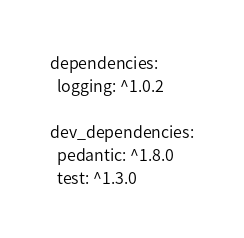<code> <loc_0><loc_0><loc_500><loc_500><_YAML_>dependencies:
  logging: ^1.0.2

dev_dependencies:
  pedantic: ^1.8.0
  test: ^1.3.0
</code> 